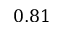Convert formula to latex. <formula><loc_0><loc_0><loc_500><loc_500>0 . 8 1</formula> 